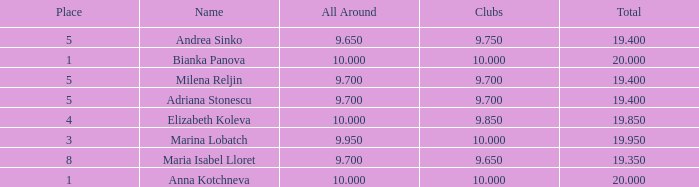What are the lowest clubs that have a place greater than 5, with an all around greater than 9.7? None. 